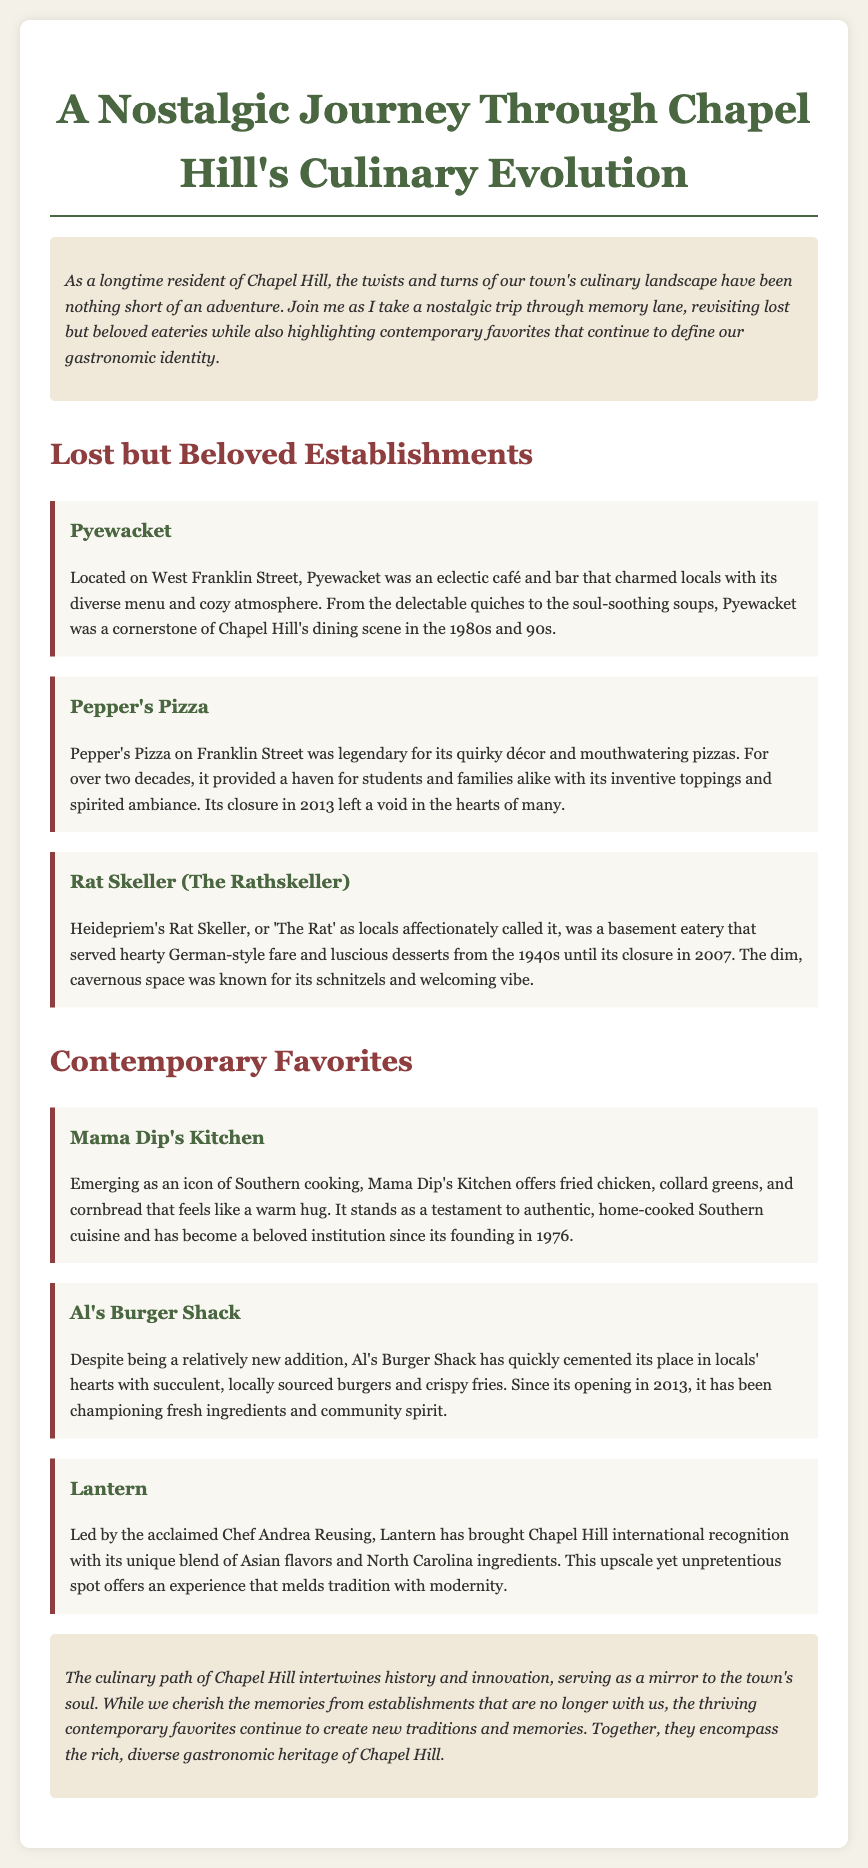What was the name of the café and bar on West Franklin Street? The document states that Pyewacket was an eclectic café and bar located on West Franklin Street.
Answer: Pyewacket In what year did Mama Dip's Kitchen open? The document indicates that Mama Dip's Kitchen was founded in 1976.
Answer: 1976 Which restaurant served German-style fare? The Rat Skeller, referred to as 'The Rat', served hearty German-style fare.
Answer: The Rat Skeller What is a contemporary favorite known for its burgers? Al's Burger Shack is highlighted as a relatively new addition known for its burgers.
Answer: Al's Burger Shack Which establishment closed in 2007? The document mentions that Heidepriem's Rat Skeller (The Rathskeller) closed in 2007.
Answer: Rat Skeller What type of cuisine does Lantern offer? The document states that Lantern offers a unique blend of Asian flavors and North Carolina ingredients.
Answer: Asian flavors and North Carolina ingredients How does the conclusion describe the relationship between lost establishments and contemporary favorites? The conclusion describes that while memories from lost establishments are cherished, contemporary favorites create new traditions and memories.
Answer: Cherished memories and new traditions What year did Pepper's Pizza close? The document specifies that Pepper's Pizza closed in 2013.
Answer: 2013 